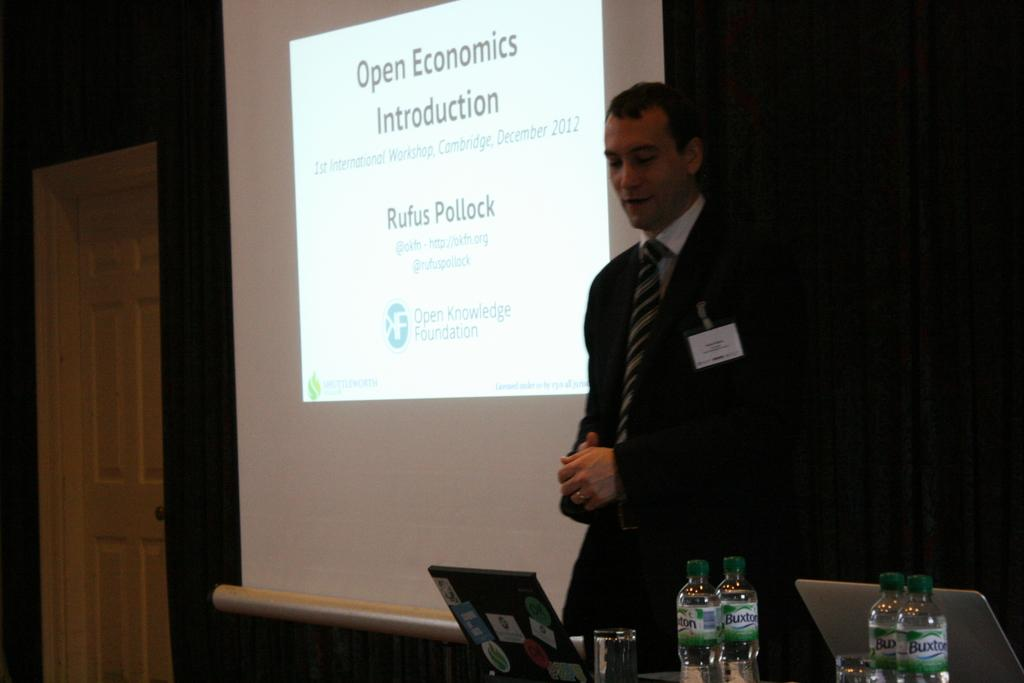What is the person in the image doing? The person is standing in front of a screen. Can you describe any architectural features in the image? Yes, there is a door in the image. What electronic devices are present on the table? There are laptops on the table. What type of beverage containers are on the table? There are bottles on the table. What is used for drinking in the image? There is a glass on the table. What type of window treatment is visible in the image? There is a black curtain in the image. How many rabbits can be seen hopping around on the table in the image? There are no rabbits present in the image. Can you describe the sound of the fly buzzing near the person in the image? There is no mention of a fly in the image, so it cannot be described. 